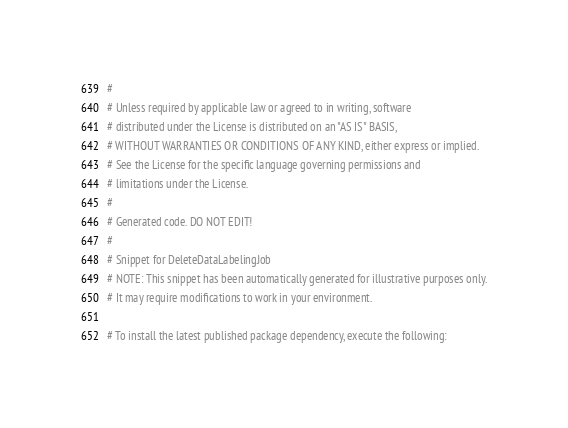<code> <loc_0><loc_0><loc_500><loc_500><_Python_>#
# Unless required by applicable law or agreed to in writing, software
# distributed under the License is distributed on an "AS IS" BASIS,
# WITHOUT WARRANTIES OR CONDITIONS OF ANY KIND, either express or implied.
# See the License for the specific language governing permissions and
# limitations under the License.
#
# Generated code. DO NOT EDIT!
#
# Snippet for DeleteDataLabelingJob
# NOTE: This snippet has been automatically generated for illustrative purposes only.
# It may require modifications to work in your environment.

# To install the latest published package dependency, execute the following:</code> 